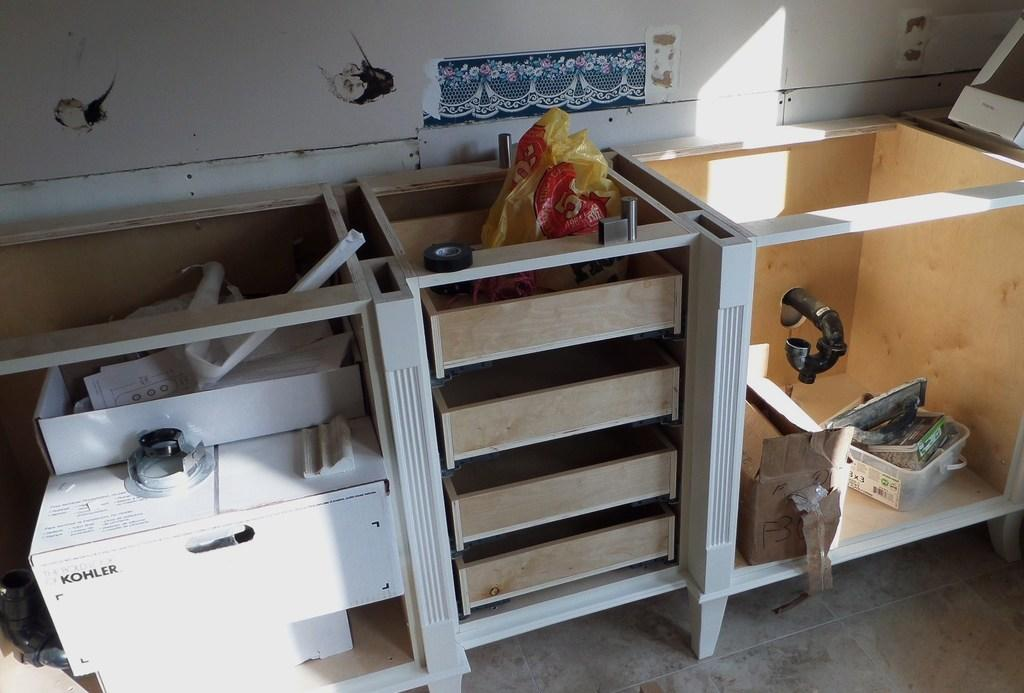What type of furniture is present in the image? There are cupboards in the image. What else can be seen in the image besides the cupboards? There are boxes in the image. What is inside the cupboards? There are objects inside the cupboards. What is the background of the image? There is a wall in the image. How does the mother interact with the boot in the image? There is no mother or boot present in the image. 